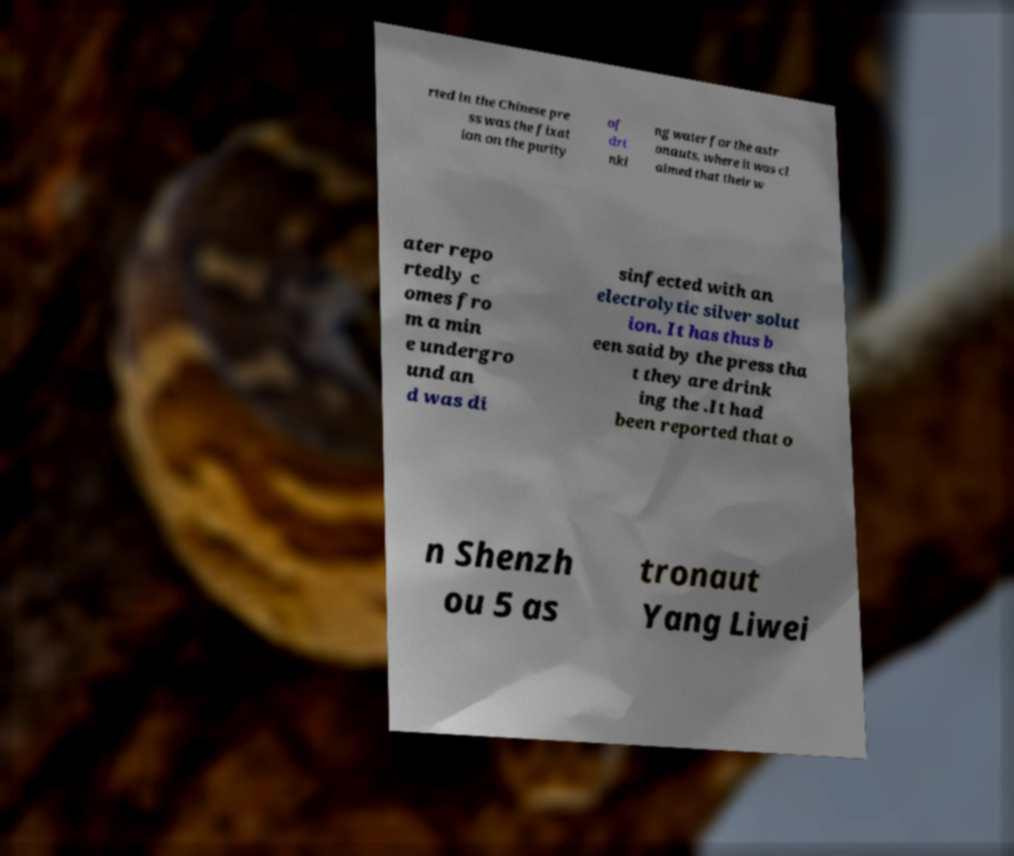For documentation purposes, I need the text within this image transcribed. Could you provide that? rted in the Chinese pre ss was the fixat ion on the purity of dri nki ng water for the astr onauts, where it was cl aimed that their w ater repo rtedly c omes fro m a min e undergro und an d was di sinfected with an electrolytic silver solut ion. It has thus b een said by the press tha t they are drink ing the .It had been reported that o n Shenzh ou 5 as tronaut Yang Liwei 